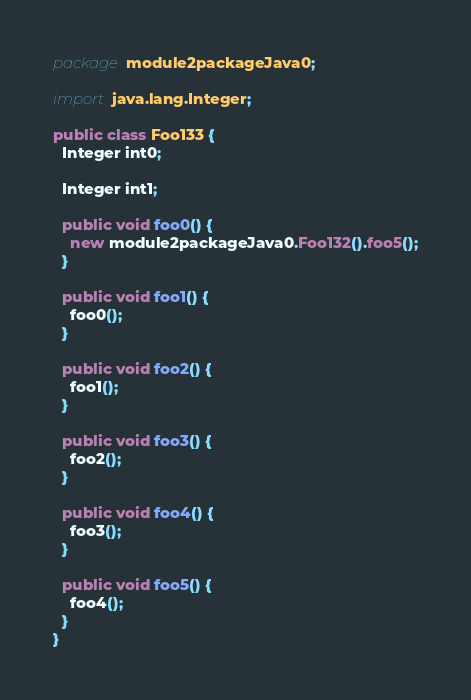<code> <loc_0><loc_0><loc_500><loc_500><_Java_>package module2packageJava0;

import java.lang.Integer;

public class Foo133 {
  Integer int0;

  Integer int1;

  public void foo0() {
    new module2packageJava0.Foo132().foo5();
  }

  public void foo1() {
    foo0();
  }

  public void foo2() {
    foo1();
  }

  public void foo3() {
    foo2();
  }

  public void foo4() {
    foo3();
  }

  public void foo5() {
    foo4();
  }
}
</code> 